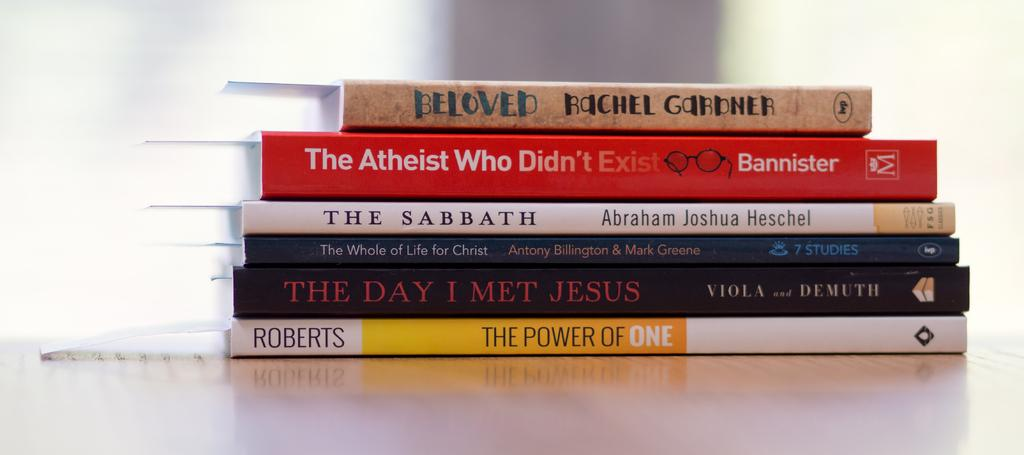<image>
Render a clear and concise summary of the photo. A stack of books with a copy of Beloved written by Rachel Gardner at the top of the stack. 